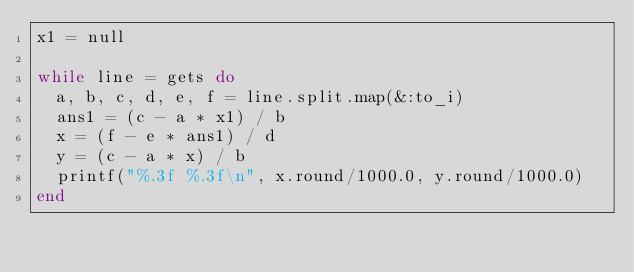Convert code to text. <code><loc_0><loc_0><loc_500><loc_500><_Ruby_>x1 = null

while line = gets do
  a, b, c, d, e, f = line.split.map(&:to_i)
  ans1 = (c - a * x1) / b
  x = (f - e * ans1) / d
  y = (c - a * x) / b
  printf("%.3f %.3f\n", x.round/1000.0, y.round/1000.0)
end</code> 